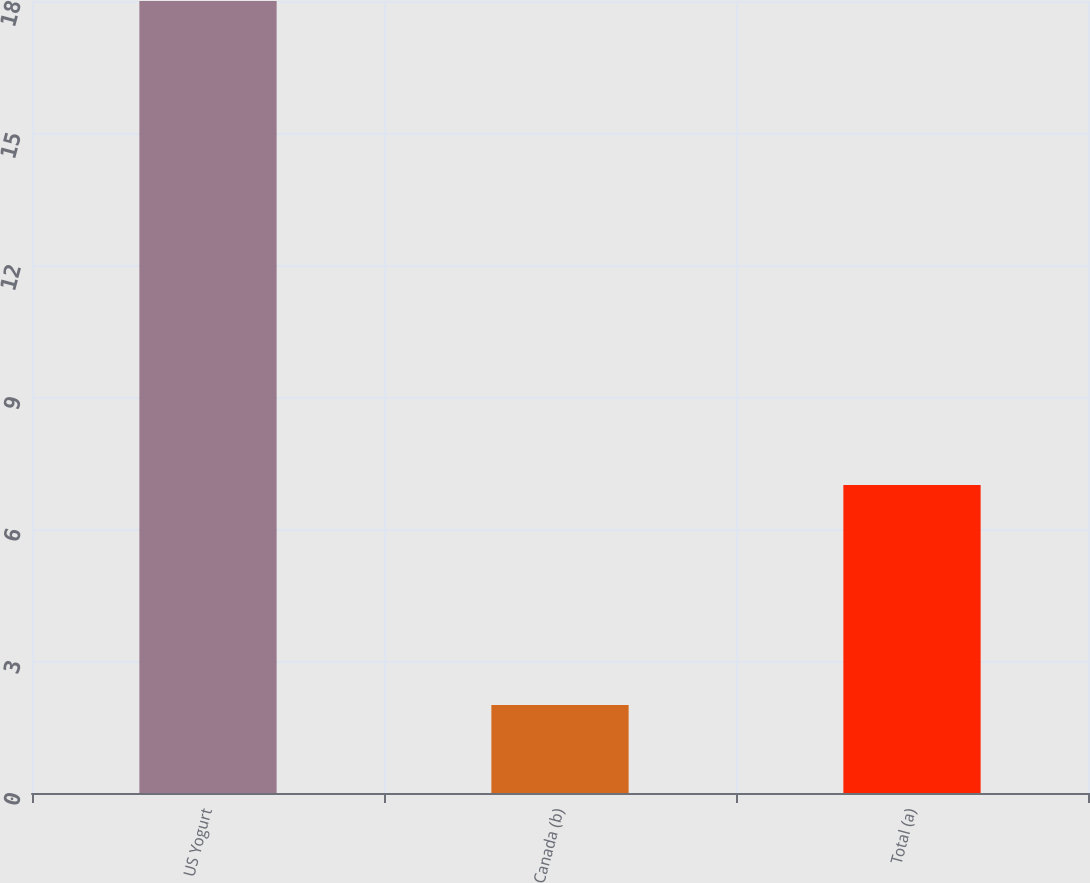Convert chart to OTSL. <chart><loc_0><loc_0><loc_500><loc_500><bar_chart><fcel>US Yogurt<fcel>Canada (b)<fcel>Total (a)<nl><fcel>18<fcel>2<fcel>7<nl></chart> 